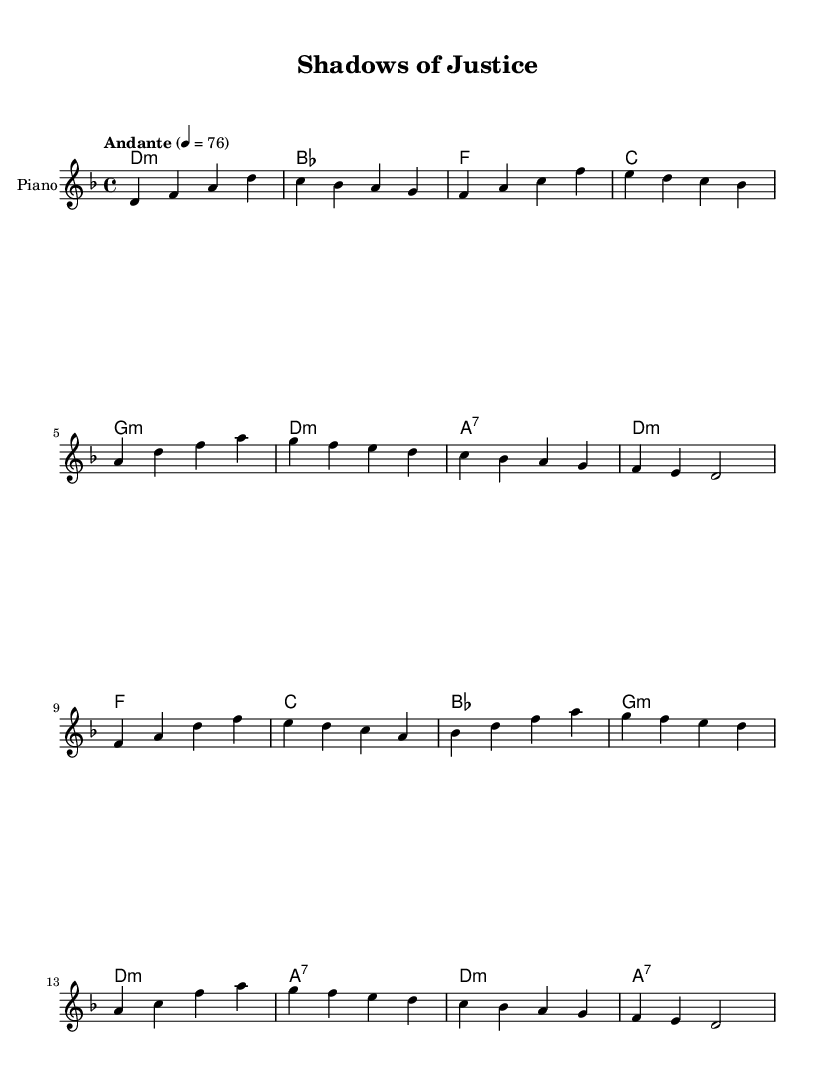What is the key signature of this music? The key signature indicates the presence of one flat, which corresponds to D minor as it has one flat (B flat).
Answer: D minor What is the time signature of this sheet music? The time signature appears as 4/4, represented by the numerator and denominator indicating four beats per measure with each beat being a quarter note.
Answer: 4/4 What tempo marking is indicated? The tempo is specified as "Andante," which generally signifies a moderate pace, specifically articulated at 76 beats per minute in this case.
Answer: Andante How many measures are in the verse section? The verse section comprises a total of eight measures, as counted from the first note until the end of the recurring harmonic sequence.
Answer: 8 What is the first chord of the chorus? The first chord in the chorus is an F major chord, indicated at the start of the chorus section, represented along with other chord symbols above the staff.
Answer: F How many unique harmonies are used throughout the piece? There are six unique harmonies utilized, as derived from the chord progression in both the verse and chorus sections laid out in the chord mode.
Answer: 6 Which theme does this piece explore related to K-Pop? The piece explores the emotional toll of high-stakes police work, as indicated by the title "Shadows of Justice," which connects with themes often found in K-Pop ballads reflecting deep emotional narratives.
Answer: Emotional toll of high-stakes police work 